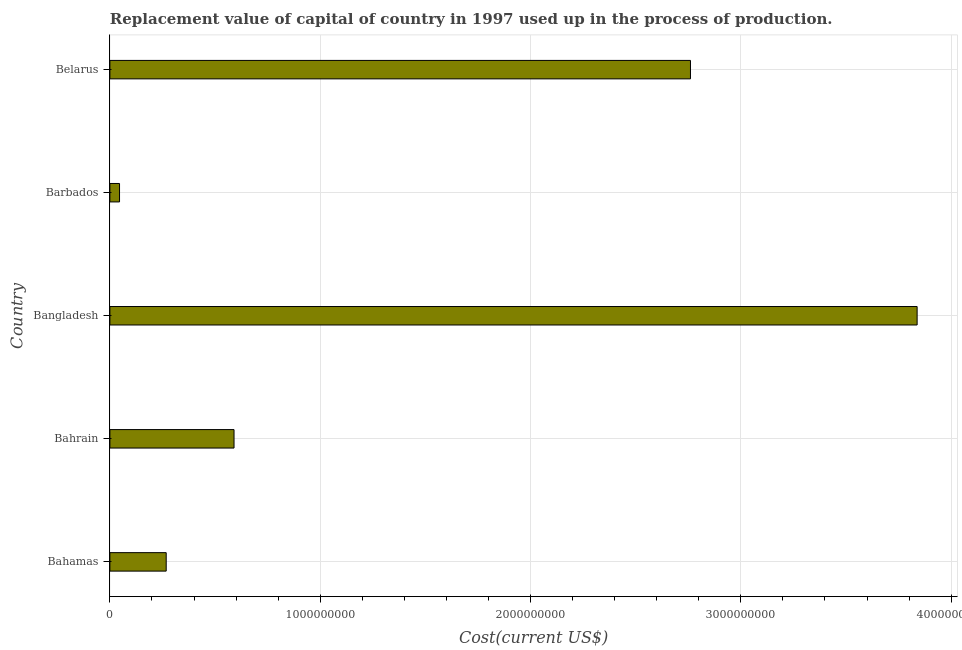Does the graph contain grids?
Offer a very short reply. Yes. What is the title of the graph?
Ensure brevity in your answer.  Replacement value of capital of country in 1997 used up in the process of production. What is the label or title of the X-axis?
Keep it short and to the point. Cost(current US$). What is the label or title of the Y-axis?
Your answer should be very brief. Country. What is the consumption of fixed capital in Bahamas?
Offer a very short reply. 2.68e+08. Across all countries, what is the maximum consumption of fixed capital?
Give a very brief answer. 3.84e+09. Across all countries, what is the minimum consumption of fixed capital?
Offer a terse response. 4.59e+07. In which country was the consumption of fixed capital minimum?
Provide a succinct answer. Barbados. What is the sum of the consumption of fixed capital?
Ensure brevity in your answer.  7.50e+09. What is the difference between the consumption of fixed capital in Bahrain and Belarus?
Make the answer very short. -2.17e+09. What is the average consumption of fixed capital per country?
Make the answer very short. 1.50e+09. What is the median consumption of fixed capital?
Make the answer very short. 5.90e+08. In how many countries, is the consumption of fixed capital greater than 2200000000 US$?
Your answer should be very brief. 2. What is the ratio of the consumption of fixed capital in Barbados to that in Belarus?
Your answer should be very brief. 0.02. Is the consumption of fixed capital in Barbados less than that in Belarus?
Ensure brevity in your answer.  Yes. What is the difference between the highest and the second highest consumption of fixed capital?
Keep it short and to the point. 1.08e+09. What is the difference between the highest and the lowest consumption of fixed capital?
Give a very brief answer. 3.79e+09. How many countries are there in the graph?
Provide a short and direct response. 5. What is the Cost(current US$) of Bahamas?
Offer a terse response. 2.68e+08. What is the Cost(current US$) of Bahrain?
Offer a terse response. 5.90e+08. What is the Cost(current US$) in Bangladesh?
Ensure brevity in your answer.  3.84e+09. What is the Cost(current US$) of Barbados?
Keep it short and to the point. 4.59e+07. What is the Cost(current US$) of Belarus?
Offer a terse response. 2.76e+09. What is the difference between the Cost(current US$) in Bahamas and Bahrain?
Offer a terse response. -3.23e+08. What is the difference between the Cost(current US$) in Bahamas and Bangladesh?
Ensure brevity in your answer.  -3.57e+09. What is the difference between the Cost(current US$) in Bahamas and Barbados?
Offer a very short reply. 2.22e+08. What is the difference between the Cost(current US$) in Bahamas and Belarus?
Your answer should be compact. -2.49e+09. What is the difference between the Cost(current US$) in Bahrain and Bangladesh?
Give a very brief answer. -3.25e+09. What is the difference between the Cost(current US$) in Bahrain and Barbados?
Provide a short and direct response. 5.44e+08. What is the difference between the Cost(current US$) in Bahrain and Belarus?
Your answer should be very brief. -2.17e+09. What is the difference between the Cost(current US$) in Bangladesh and Barbados?
Offer a very short reply. 3.79e+09. What is the difference between the Cost(current US$) in Bangladesh and Belarus?
Your response must be concise. 1.08e+09. What is the difference between the Cost(current US$) in Barbados and Belarus?
Provide a succinct answer. -2.71e+09. What is the ratio of the Cost(current US$) in Bahamas to that in Bahrain?
Make the answer very short. 0.45. What is the ratio of the Cost(current US$) in Bahamas to that in Bangladesh?
Your answer should be very brief. 0.07. What is the ratio of the Cost(current US$) in Bahamas to that in Barbados?
Your answer should be compact. 5.84. What is the ratio of the Cost(current US$) in Bahamas to that in Belarus?
Provide a succinct answer. 0.1. What is the ratio of the Cost(current US$) in Bahrain to that in Bangladesh?
Make the answer very short. 0.15. What is the ratio of the Cost(current US$) in Bahrain to that in Barbados?
Your response must be concise. 12.87. What is the ratio of the Cost(current US$) in Bahrain to that in Belarus?
Your answer should be very brief. 0.21. What is the ratio of the Cost(current US$) in Bangladesh to that in Barbados?
Keep it short and to the point. 83.69. What is the ratio of the Cost(current US$) in Bangladesh to that in Belarus?
Offer a very short reply. 1.39. What is the ratio of the Cost(current US$) in Barbados to that in Belarus?
Provide a succinct answer. 0.02. 